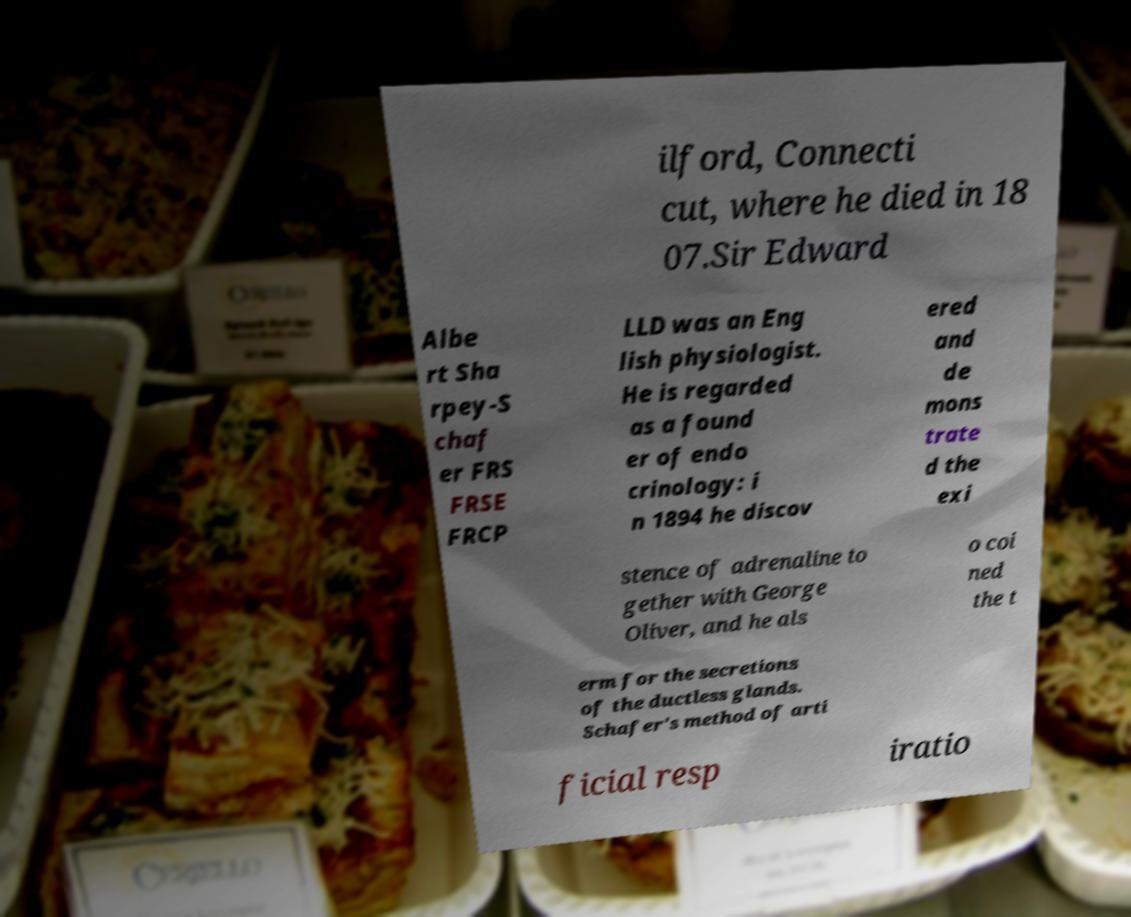Can you read and provide the text displayed in the image?This photo seems to have some interesting text. Can you extract and type it out for me? ilford, Connecti cut, where he died in 18 07.Sir Edward Albe rt Sha rpey-S chaf er FRS FRSE FRCP LLD was an Eng lish physiologist. He is regarded as a found er of endo crinology: i n 1894 he discov ered and de mons trate d the exi stence of adrenaline to gether with George Oliver, and he als o coi ned the t erm for the secretions of the ductless glands. Schafer's method of arti ficial resp iratio 